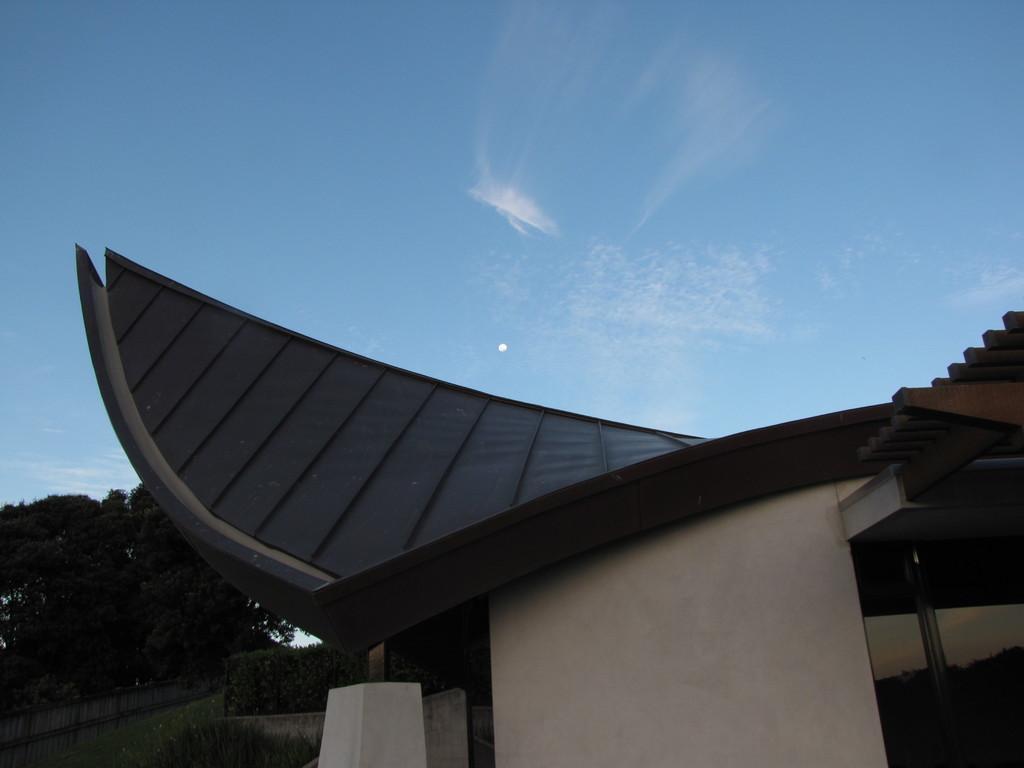Could you give a brief overview of what you see in this image? In this picture we can see grass at the bottom, in the background there are trees, we can see a building here, there is the sky at the top of the picture. 